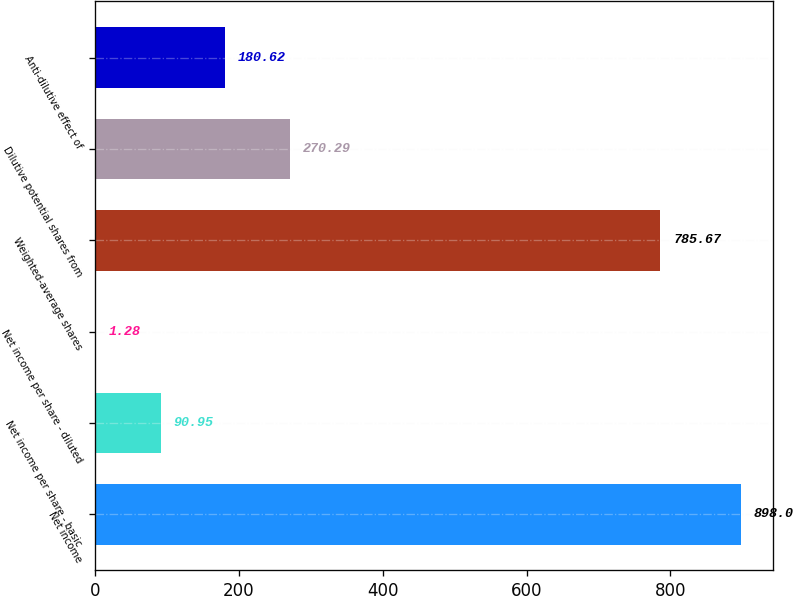Convert chart. <chart><loc_0><loc_0><loc_500><loc_500><bar_chart><fcel>Net income<fcel>Net income per share - basic<fcel>Net income per share - diluted<fcel>Weighted-average shares<fcel>Dilutive potential shares from<fcel>Anti-dilutive effect of<nl><fcel>898<fcel>90.95<fcel>1.28<fcel>785.67<fcel>270.29<fcel>180.62<nl></chart> 